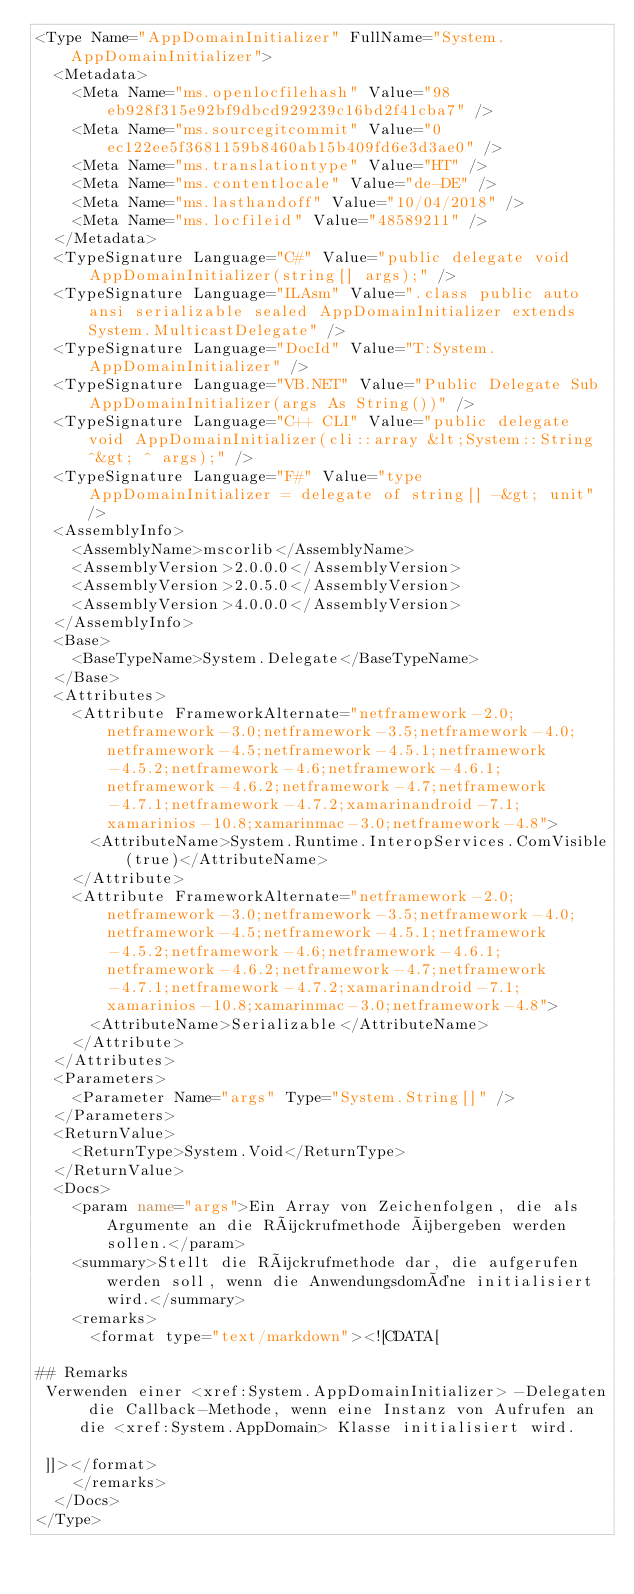<code> <loc_0><loc_0><loc_500><loc_500><_XML_><Type Name="AppDomainInitializer" FullName="System.AppDomainInitializer">
  <Metadata>
    <Meta Name="ms.openlocfilehash" Value="98eb928f315e92bf9dbcd929239c16bd2f41cba7" />
    <Meta Name="ms.sourcegitcommit" Value="0ec122ee5f3681159b8460ab15b409fd6e3d3ae0" />
    <Meta Name="ms.translationtype" Value="HT" />
    <Meta Name="ms.contentlocale" Value="de-DE" />
    <Meta Name="ms.lasthandoff" Value="10/04/2018" />
    <Meta Name="ms.locfileid" Value="48589211" />
  </Metadata>
  <TypeSignature Language="C#" Value="public delegate void AppDomainInitializer(string[] args);" />
  <TypeSignature Language="ILAsm" Value=".class public auto ansi serializable sealed AppDomainInitializer extends System.MulticastDelegate" />
  <TypeSignature Language="DocId" Value="T:System.AppDomainInitializer" />
  <TypeSignature Language="VB.NET" Value="Public Delegate Sub AppDomainInitializer(args As String())" />
  <TypeSignature Language="C++ CLI" Value="public delegate void AppDomainInitializer(cli::array &lt;System::String ^&gt; ^ args);" />
  <TypeSignature Language="F#" Value="type AppDomainInitializer = delegate of string[] -&gt; unit" />
  <AssemblyInfo>
    <AssemblyName>mscorlib</AssemblyName>
    <AssemblyVersion>2.0.0.0</AssemblyVersion>
    <AssemblyVersion>2.0.5.0</AssemblyVersion>
    <AssemblyVersion>4.0.0.0</AssemblyVersion>
  </AssemblyInfo>
  <Base>
    <BaseTypeName>System.Delegate</BaseTypeName>
  </Base>
  <Attributes>
    <Attribute FrameworkAlternate="netframework-2.0;netframework-3.0;netframework-3.5;netframework-4.0;netframework-4.5;netframework-4.5.1;netframework-4.5.2;netframework-4.6;netframework-4.6.1;netframework-4.6.2;netframework-4.7;netframework-4.7.1;netframework-4.7.2;xamarinandroid-7.1;xamarinios-10.8;xamarinmac-3.0;netframework-4.8">
      <AttributeName>System.Runtime.InteropServices.ComVisible(true)</AttributeName>
    </Attribute>
    <Attribute FrameworkAlternate="netframework-2.0;netframework-3.0;netframework-3.5;netframework-4.0;netframework-4.5;netframework-4.5.1;netframework-4.5.2;netframework-4.6;netframework-4.6.1;netframework-4.6.2;netframework-4.7;netframework-4.7.1;netframework-4.7.2;xamarinandroid-7.1;xamarinios-10.8;xamarinmac-3.0;netframework-4.8">
      <AttributeName>Serializable</AttributeName>
    </Attribute>
  </Attributes>
  <Parameters>
    <Parameter Name="args" Type="System.String[]" />
  </Parameters>
  <ReturnValue>
    <ReturnType>System.Void</ReturnType>
  </ReturnValue>
  <Docs>
    <param name="args">Ein Array von Zeichenfolgen, die als Argumente an die Rückrufmethode übergeben werden sollen.</param>
    <summary>Stellt die Rückrufmethode dar, die aufgerufen werden soll, wenn die Anwendungsdomäne initialisiert wird.</summary>
    <remarks>
      <format type="text/markdown"><![CDATA[  
  
## Remarks  
 Verwenden einer <xref:System.AppDomainInitializer> -Delegaten die Callback-Methode, wenn eine Instanz von Aufrufen an die <xref:System.AppDomain> Klasse initialisiert wird.  
  
 ]]></format>
    </remarks>
  </Docs>
</Type></code> 